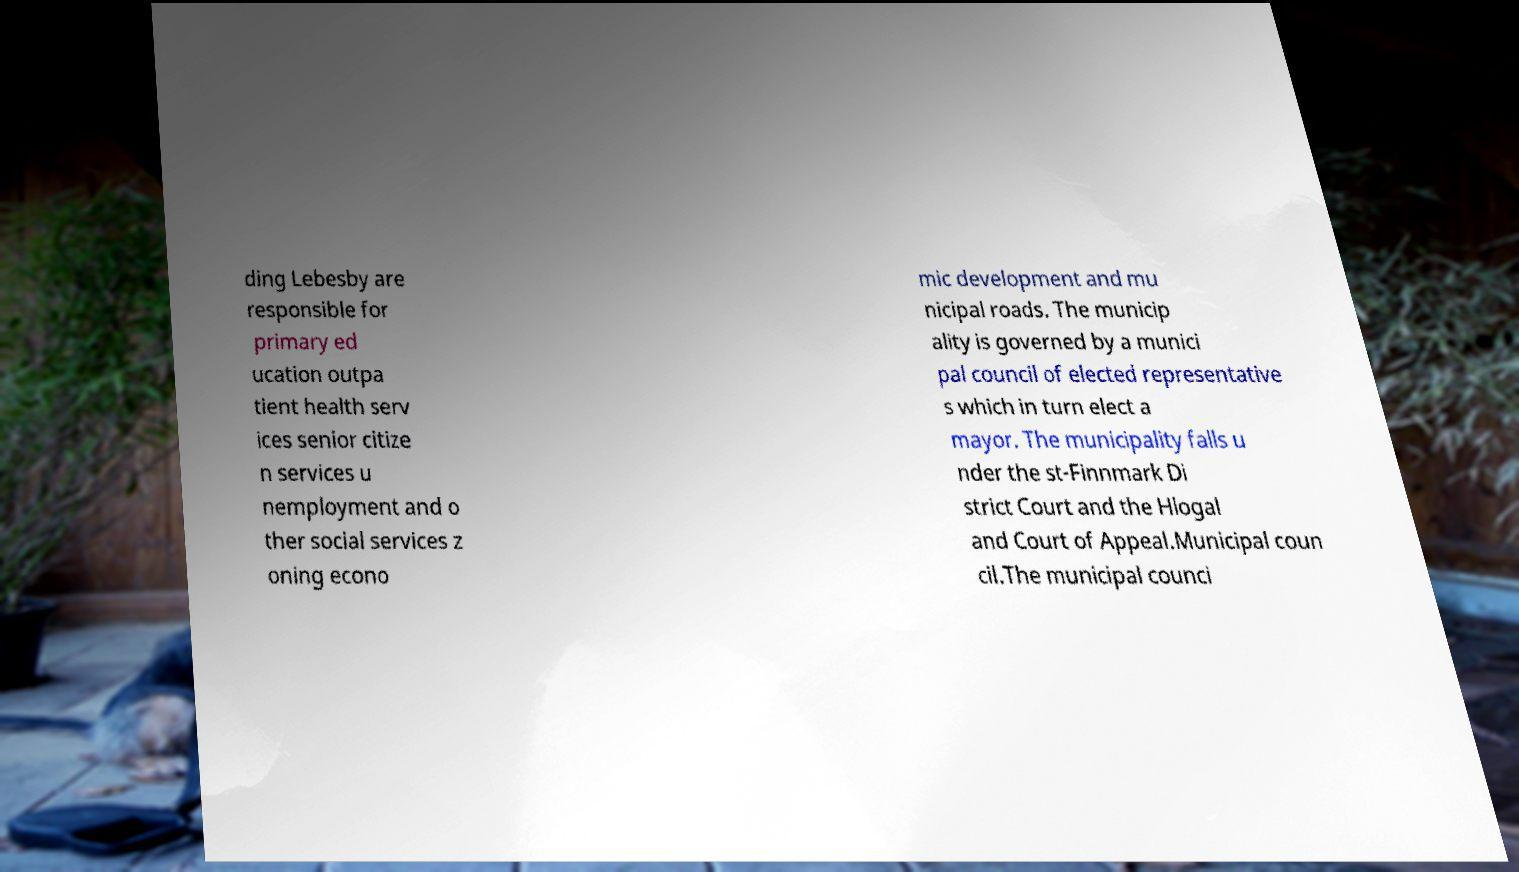Could you assist in decoding the text presented in this image and type it out clearly? ding Lebesby are responsible for primary ed ucation outpa tient health serv ices senior citize n services u nemployment and o ther social services z oning econo mic development and mu nicipal roads. The municip ality is governed by a munici pal council of elected representative s which in turn elect a mayor. The municipality falls u nder the st-Finnmark Di strict Court and the Hlogal and Court of Appeal.Municipal coun cil.The municipal counci 